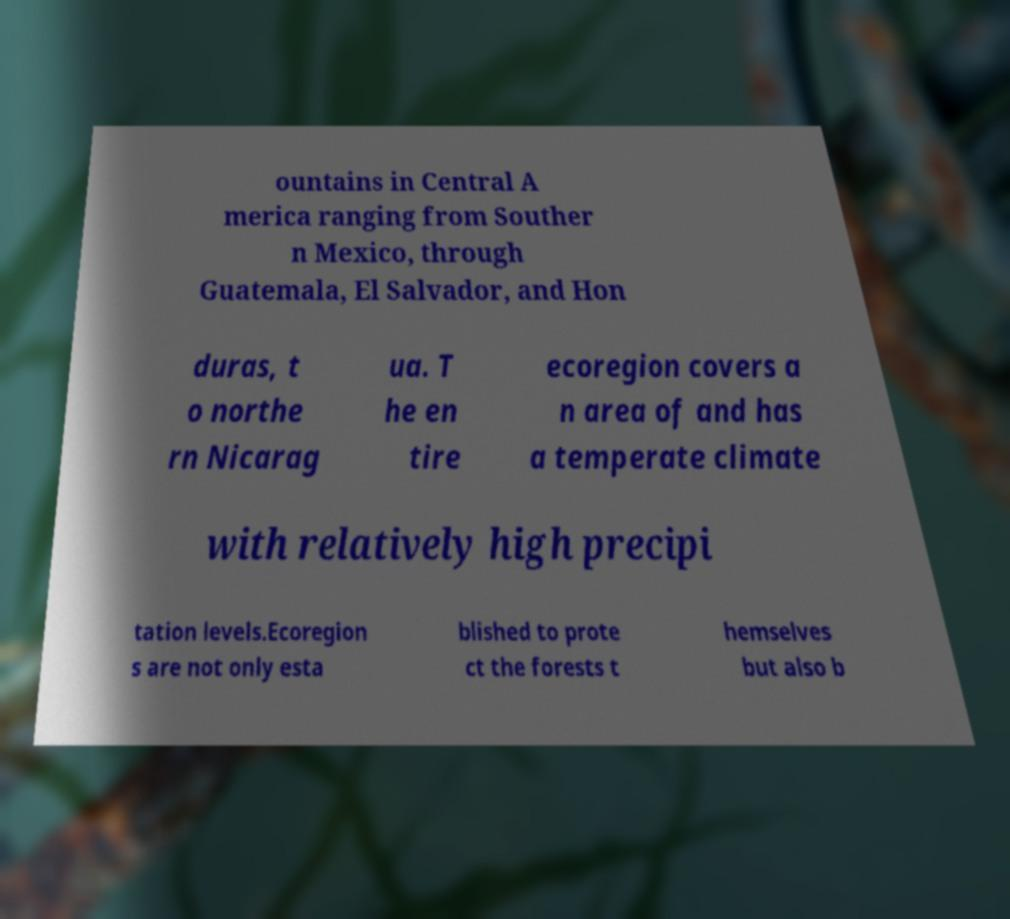Could you assist in decoding the text presented in this image and type it out clearly? ountains in Central A merica ranging from Souther n Mexico, through Guatemala, El Salvador, and Hon duras, t o northe rn Nicarag ua. T he en tire ecoregion covers a n area of and has a temperate climate with relatively high precipi tation levels.Ecoregion s are not only esta blished to prote ct the forests t hemselves but also b 